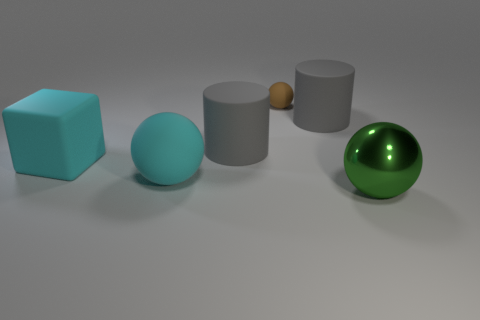Are there any other things that are the same material as the green ball?
Your answer should be compact. No. What number of other objects are the same size as the brown rubber ball?
Provide a succinct answer. 0. Are there more big cyan balls than big gray matte cylinders?
Ensure brevity in your answer.  No. How many big things are to the right of the brown matte object and behind the large metallic sphere?
Offer a very short reply. 1. What is the shape of the big gray matte object to the right of the sphere that is behind the matte ball that is in front of the tiny brown thing?
Keep it short and to the point. Cylinder. How many cubes are big green things or large blue matte things?
Ensure brevity in your answer.  0. Do the large cylinder that is to the left of the tiny sphere and the shiny object have the same color?
Provide a succinct answer. No. What material is the ball left of the matte sphere that is to the right of the big ball behind the large green metallic sphere?
Your answer should be compact. Rubber. Do the cyan rubber sphere and the block have the same size?
Ensure brevity in your answer.  Yes. Do the big rubber sphere and the big matte cylinder that is on the right side of the brown matte object have the same color?
Your answer should be compact. No. 